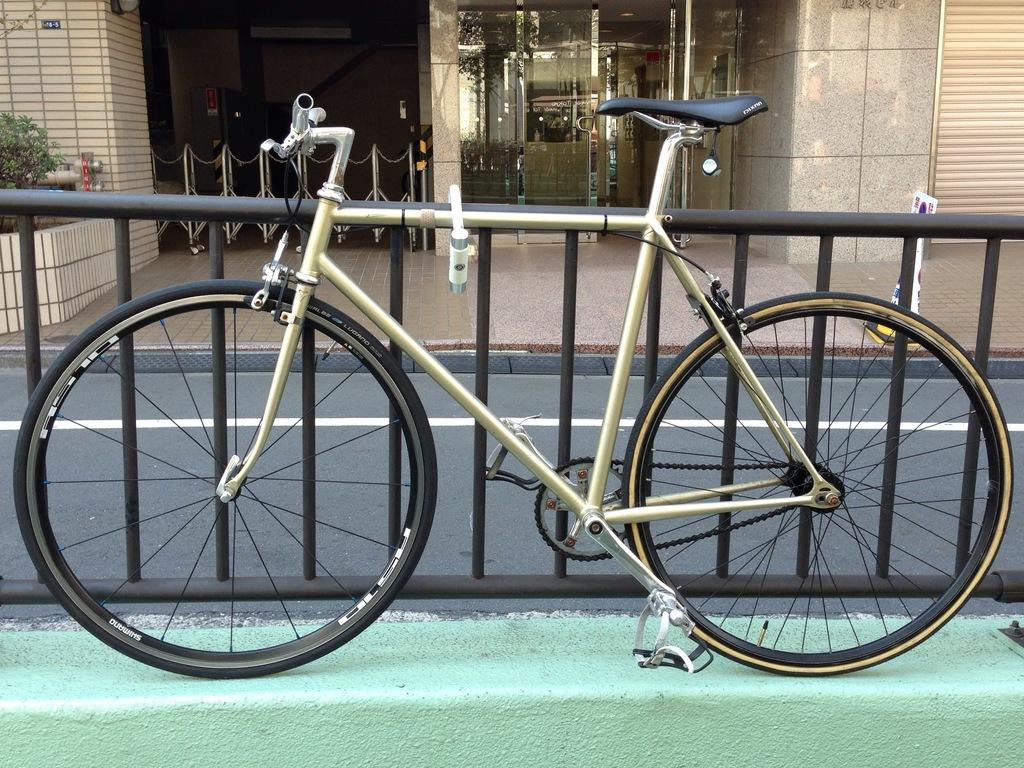What is located in the center of the image? There is a fence in the center of the image. What can be seen on the wall in the image? There is a cycle on the wall in the image. What is visible in the background of the image? There is a building, glass, a plant, and a road in the background of the image. Can you describe the other objects in the background of the image? There are a few other objects in the background of the image, but their specific details are not mentioned in the provided facts. What type of prison is depicted in the image? There is no prison present in the image. What kind of linen is used to cover the objects in the image? There is no linen present in the image. 